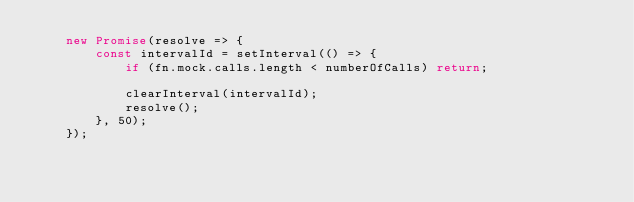<code> <loc_0><loc_0><loc_500><loc_500><_TypeScript_>    new Promise(resolve => {
        const intervalId = setInterval(() => {
            if (fn.mock.calls.length < numberOfCalls) return;

            clearInterval(intervalId);
            resolve();
        }, 50);
    });
</code> 